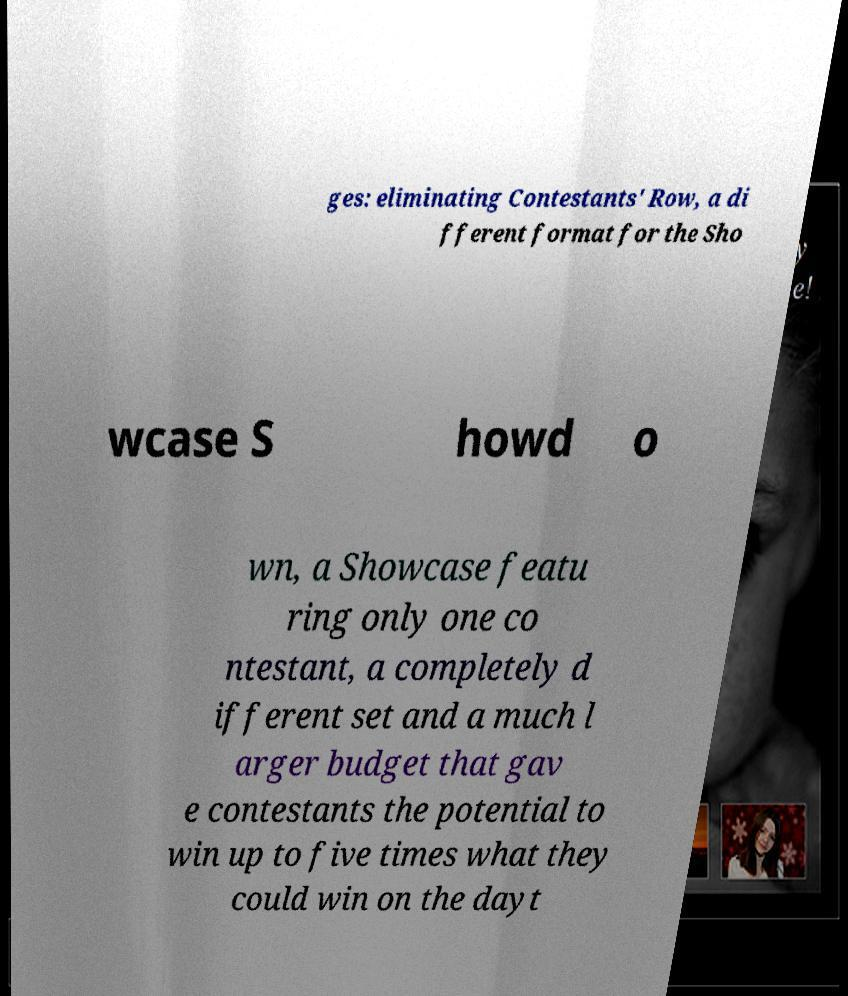Can you accurately transcribe the text from the provided image for me? ges: eliminating Contestants' Row, a di fferent format for the Sho wcase S howd o wn, a Showcase featu ring only one co ntestant, a completely d ifferent set and a much l arger budget that gav e contestants the potential to win up to five times what they could win on the dayt 